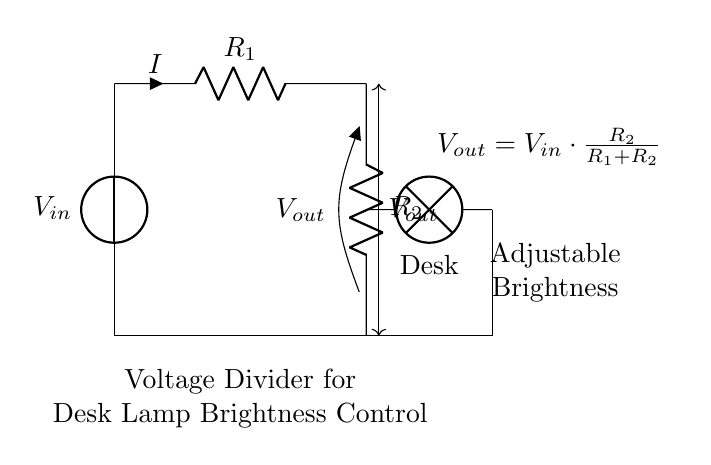What does the lamp represent in this circuit? The lamp represents the load that requires the electrical energy to produce light, indicated as a component in the circuit connected to the output voltage.
Answer: Desk What is the purpose of the voltage divider in this circuit? The voltage divider adjusts the voltage applied to the lamp, thereby controlling its brightness by providing a reduced output voltage from the input supply.
Answer: Brightness control What is the relationship between R1 and R2 to determine Vout? Vout is determined by the ratio of R2 to the total resistance (R1 + R2), according to the voltage divider formula, which influences the brightness of the lamp.
Answer: R2/(R1+R2) What is the nature of the current flowing through R1? The current flowing through R1 is the same as the current through R2 because they are in series; thus, despite the voltage drop, the current remains constant.
Answer: I What happens to Vout when R2 increases? If R2 increases while R1 remains constant, the ratio of R2/(R1 + R2) increases, leading to a higher output voltage and increased brightness of the lamp.
Answer: Vout increases What is the formula used to calculate Vout in this circuit? The formula for Vout in this voltage divider circuit is given by Vout = Vin * (R2 / (R1 + R2)), providing a mathematical relationship between the input and output voltages.
Answer: Vout = Vin * (R2/(R1+R2)) 